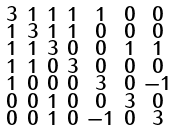<formula> <loc_0><loc_0><loc_500><loc_500>\begin{smallmatrix} 3 & 1 & 1 & 1 & 1 & 0 & 0 \\ 1 & 3 & 1 & 1 & 0 & 0 & 0 \\ 1 & 1 & 3 & 0 & 0 & 1 & 1 \\ 1 & 1 & 0 & 3 & 0 & 0 & 0 \\ 1 & 0 & 0 & 0 & 3 & 0 & - 1 \\ 0 & 0 & 1 & 0 & 0 & 3 & 0 \\ 0 & 0 & 1 & 0 & - 1 & 0 & 3 \end{smallmatrix}</formula> 